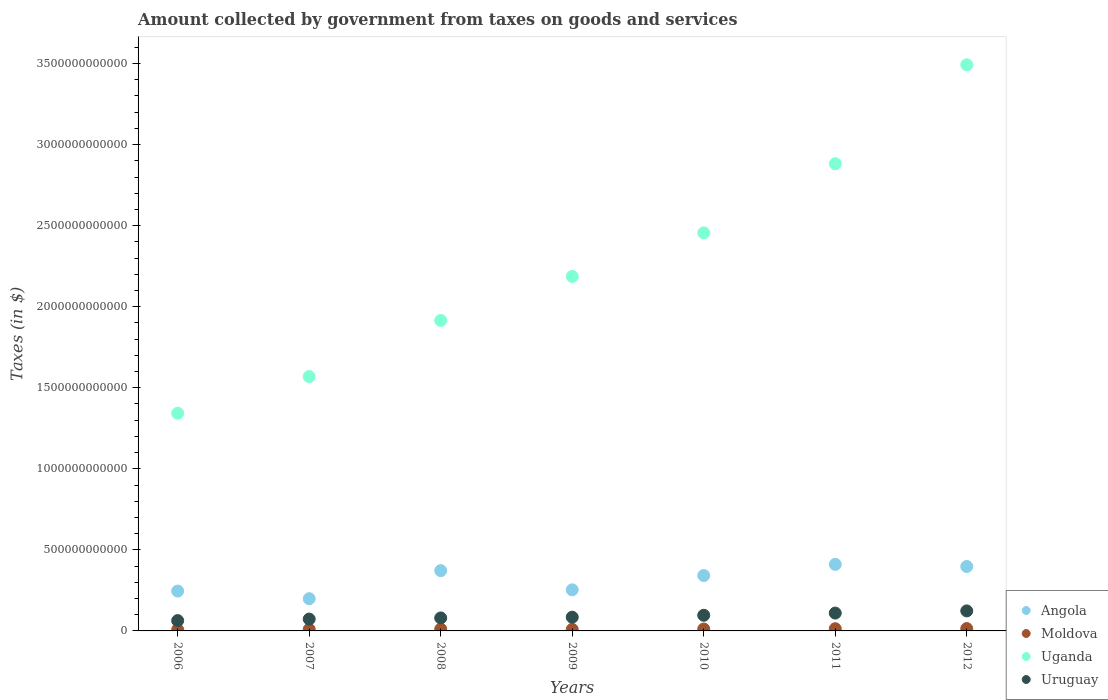What is the amount collected by government from taxes on goods and services in Uganda in 2010?
Your response must be concise. 2.46e+12. Across all years, what is the maximum amount collected by government from taxes on goods and services in Uganda?
Keep it short and to the point. 3.49e+12. Across all years, what is the minimum amount collected by government from taxes on goods and services in Uruguay?
Provide a succinct answer. 6.36e+1. What is the total amount collected by government from taxes on goods and services in Uganda in the graph?
Ensure brevity in your answer.  1.58e+13. What is the difference between the amount collected by government from taxes on goods and services in Uganda in 2008 and that in 2009?
Make the answer very short. -2.71e+11. What is the difference between the amount collected by government from taxes on goods and services in Uganda in 2006 and the amount collected by government from taxes on goods and services in Angola in 2010?
Offer a very short reply. 1.00e+12. What is the average amount collected by government from taxes on goods and services in Uruguay per year?
Keep it short and to the point. 9.02e+1. In the year 2009, what is the difference between the amount collected by government from taxes on goods and services in Angola and amount collected by government from taxes on goods and services in Uruguay?
Provide a succinct answer. 1.69e+11. In how many years, is the amount collected by government from taxes on goods and services in Angola greater than 100000000000 $?
Offer a very short reply. 7. What is the ratio of the amount collected by government from taxes on goods and services in Moldova in 2007 to that in 2011?
Your answer should be very brief. 0.69. What is the difference between the highest and the second highest amount collected by government from taxes on goods and services in Uruguay?
Offer a terse response. 1.34e+1. What is the difference between the highest and the lowest amount collected by government from taxes on goods and services in Moldova?
Your answer should be very brief. 6.71e+09. In how many years, is the amount collected by government from taxes on goods and services in Angola greater than the average amount collected by government from taxes on goods and services in Angola taken over all years?
Provide a succinct answer. 4. Does the amount collected by government from taxes on goods and services in Uruguay monotonically increase over the years?
Give a very brief answer. Yes. How many dotlines are there?
Give a very brief answer. 4. How many years are there in the graph?
Make the answer very short. 7. What is the difference between two consecutive major ticks on the Y-axis?
Give a very brief answer. 5.00e+11. Does the graph contain any zero values?
Your response must be concise. No. Does the graph contain grids?
Offer a terse response. No. Where does the legend appear in the graph?
Provide a short and direct response. Bottom right. How many legend labels are there?
Keep it short and to the point. 4. What is the title of the graph?
Give a very brief answer. Amount collected by government from taxes on goods and services. Does "Sri Lanka" appear as one of the legend labels in the graph?
Make the answer very short. No. What is the label or title of the X-axis?
Your response must be concise. Years. What is the label or title of the Y-axis?
Provide a short and direct response. Taxes (in $). What is the Taxes (in $) in Angola in 2006?
Provide a short and direct response. 2.46e+11. What is the Taxes (in $) in Moldova in 2006?
Provide a succinct answer. 7.69e+09. What is the Taxes (in $) of Uganda in 2006?
Provide a succinct answer. 1.34e+12. What is the Taxes (in $) in Uruguay in 2006?
Provide a succinct answer. 6.36e+1. What is the Taxes (in $) of Angola in 2007?
Keep it short and to the point. 1.99e+11. What is the Taxes (in $) of Moldova in 2007?
Your answer should be very brief. 9.43e+09. What is the Taxes (in $) in Uganda in 2007?
Ensure brevity in your answer.  1.57e+12. What is the Taxes (in $) in Uruguay in 2007?
Provide a succinct answer. 7.31e+1. What is the Taxes (in $) of Angola in 2008?
Make the answer very short. 3.72e+11. What is the Taxes (in $) in Moldova in 2008?
Keep it short and to the point. 1.14e+1. What is the Taxes (in $) in Uganda in 2008?
Your answer should be very brief. 1.92e+12. What is the Taxes (in $) in Uruguay in 2008?
Ensure brevity in your answer.  8.00e+1. What is the Taxes (in $) of Angola in 2009?
Offer a terse response. 2.53e+11. What is the Taxes (in $) of Moldova in 2009?
Offer a very short reply. 9.60e+09. What is the Taxes (in $) of Uganda in 2009?
Offer a very short reply. 2.19e+12. What is the Taxes (in $) in Uruguay in 2009?
Your answer should be very brief. 8.47e+1. What is the Taxes (in $) in Angola in 2010?
Give a very brief answer. 3.42e+11. What is the Taxes (in $) of Moldova in 2010?
Ensure brevity in your answer.  1.18e+1. What is the Taxes (in $) in Uganda in 2010?
Your response must be concise. 2.46e+12. What is the Taxes (in $) in Uruguay in 2010?
Your answer should be compact. 9.64e+1. What is the Taxes (in $) in Angola in 2011?
Offer a very short reply. 4.10e+11. What is the Taxes (in $) in Moldova in 2011?
Offer a very short reply. 1.36e+1. What is the Taxes (in $) of Uganda in 2011?
Provide a succinct answer. 2.88e+12. What is the Taxes (in $) in Uruguay in 2011?
Give a very brief answer. 1.10e+11. What is the Taxes (in $) of Angola in 2012?
Make the answer very short. 3.98e+11. What is the Taxes (in $) in Moldova in 2012?
Make the answer very short. 1.44e+1. What is the Taxes (in $) in Uganda in 2012?
Your answer should be very brief. 3.49e+12. What is the Taxes (in $) of Uruguay in 2012?
Provide a short and direct response. 1.23e+11. Across all years, what is the maximum Taxes (in $) in Angola?
Ensure brevity in your answer.  4.10e+11. Across all years, what is the maximum Taxes (in $) in Moldova?
Ensure brevity in your answer.  1.44e+1. Across all years, what is the maximum Taxes (in $) in Uganda?
Your response must be concise. 3.49e+12. Across all years, what is the maximum Taxes (in $) of Uruguay?
Provide a succinct answer. 1.23e+11. Across all years, what is the minimum Taxes (in $) of Angola?
Ensure brevity in your answer.  1.99e+11. Across all years, what is the minimum Taxes (in $) in Moldova?
Provide a succinct answer. 7.69e+09. Across all years, what is the minimum Taxes (in $) in Uganda?
Offer a terse response. 1.34e+12. Across all years, what is the minimum Taxes (in $) of Uruguay?
Ensure brevity in your answer.  6.36e+1. What is the total Taxes (in $) of Angola in the graph?
Ensure brevity in your answer.  2.22e+12. What is the total Taxes (in $) in Moldova in the graph?
Your answer should be compact. 7.79e+1. What is the total Taxes (in $) of Uganda in the graph?
Your answer should be compact. 1.58e+13. What is the total Taxes (in $) of Uruguay in the graph?
Your response must be concise. 6.31e+11. What is the difference between the Taxes (in $) in Angola in 2006 and that in 2007?
Ensure brevity in your answer.  4.70e+1. What is the difference between the Taxes (in $) of Moldova in 2006 and that in 2007?
Ensure brevity in your answer.  -1.74e+09. What is the difference between the Taxes (in $) of Uganda in 2006 and that in 2007?
Make the answer very short. -2.26e+11. What is the difference between the Taxes (in $) of Uruguay in 2006 and that in 2007?
Offer a terse response. -9.46e+09. What is the difference between the Taxes (in $) of Angola in 2006 and that in 2008?
Your answer should be compact. -1.26e+11. What is the difference between the Taxes (in $) of Moldova in 2006 and that in 2008?
Provide a succinct answer. -3.71e+09. What is the difference between the Taxes (in $) in Uganda in 2006 and that in 2008?
Offer a very short reply. -5.72e+11. What is the difference between the Taxes (in $) of Uruguay in 2006 and that in 2008?
Offer a terse response. -1.64e+1. What is the difference between the Taxes (in $) in Angola in 2006 and that in 2009?
Your answer should be very brief. -7.65e+09. What is the difference between the Taxes (in $) of Moldova in 2006 and that in 2009?
Keep it short and to the point. -1.91e+09. What is the difference between the Taxes (in $) of Uganda in 2006 and that in 2009?
Offer a very short reply. -8.44e+11. What is the difference between the Taxes (in $) in Uruguay in 2006 and that in 2009?
Offer a very short reply. -2.10e+1. What is the difference between the Taxes (in $) in Angola in 2006 and that in 2010?
Offer a very short reply. -9.57e+1. What is the difference between the Taxes (in $) of Moldova in 2006 and that in 2010?
Make the answer very short. -4.10e+09. What is the difference between the Taxes (in $) in Uganda in 2006 and that in 2010?
Keep it short and to the point. -1.11e+12. What is the difference between the Taxes (in $) in Uruguay in 2006 and that in 2010?
Make the answer very short. -3.28e+1. What is the difference between the Taxes (in $) of Angola in 2006 and that in 2011?
Provide a short and direct response. -1.65e+11. What is the difference between the Taxes (in $) in Moldova in 2006 and that in 2011?
Make the answer very short. -5.93e+09. What is the difference between the Taxes (in $) of Uganda in 2006 and that in 2011?
Provide a succinct answer. -1.54e+12. What is the difference between the Taxes (in $) in Uruguay in 2006 and that in 2011?
Make the answer very short. -4.64e+1. What is the difference between the Taxes (in $) of Angola in 2006 and that in 2012?
Your response must be concise. -1.52e+11. What is the difference between the Taxes (in $) of Moldova in 2006 and that in 2012?
Your answer should be compact. -6.71e+09. What is the difference between the Taxes (in $) in Uganda in 2006 and that in 2012?
Offer a terse response. -2.15e+12. What is the difference between the Taxes (in $) of Uruguay in 2006 and that in 2012?
Your answer should be compact. -5.98e+1. What is the difference between the Taxes (in $) of Angola in 2007 and that in 2008?
Your answer should be very brief. -1.73e+11. What is the difference between the Taxes (in $) in Moldova in 2007 and that in 2008?
Your answer should be very brief. -1.97e+09. What is the difference between the Taxes (in $) in Uganda in 2007 and that in 2008?
Your response must be concise. -3.46e+11. What is the difference between the Taxes (in $) of Uruguay in 2007 and that in 2008?
Provide a short and direct response. -6.92e+09. What is the difference between the Taxes (in $) in Angola in 2007 and that in 2009?
Offer a very short reply. -5.47e+1. What is the difference between the Taxes (in $) in Moldova in 2007 and that in 2009?
Offer a terse response. -1.71e+08. What is the difference between the Taxes (in $) in Uganda in 2007 and that in 2009?
Ensure brevity in your answer.  -6.18e+11. What is the difference between the Taxes (in $) in Uruguay in 2007 and that in 2009?
Provide a succinct answer. -1.16e+1. What is the difference between the Taxes (in $) in Angola in 2007 and that in 2010?
Provide a succinct answer. -1.43e+11. What is the difference between the Taxes (in $) of Moldova in 2007 and that in 2010?
Provide a succinct answer. -2.36e+09. What is the difference between the Taxes (in $) of Uganda in 2007 and that in 2010?
Ensure brevity in your answer.  -8.86e+11. What is the difference between the Taxes (in $) of Uruguay in 2007 and that in 2010?
Make the answer very short. -2.33e+1. What is the difference between the Taxes (in $) of Angola in 2007 and that in 2011?
Provide a short and direct response. -2.12e+11. What is the difference between the Taxes (in $) of Moldova in 2007 and that in 2011?
Provide a succinct answer. -4.19e+09. What is the difference between the Taxes (in $) of Uganda in 2007 and that in 2011?
Your answer should be compact. -1.31e+12. What is the difference between the Taxes (in $) in Uruguay in 2007 and that in 2011?
Offer a terse response. -3.69e+1. What is the difference between the Taxes (in $) of Angola in 2007 and that in 2012?
Your answer should be compact. -1.99e+11. What is the difference between the Taxes (in $) in Moldova in 2007 and that in 2012?
Your response must be concise. -4.97e+09. What is the difference between the Taxes (in $) of Uganda in 2007 and that in 2012?
Your answer should be compact. -1.92e+12. What is the difference between the Taxes (in $) of Uruguay in 2007 and that in 2012?
Keep it short and to the point. -5.03e+1. What is the difference between the Taxes (in $) in Angola in 2008 and that in 2009?
Offer a very short reply. 1.18e+11. What is the difference between the Taxes (in $) of Moldova in 2008 and that in 2009?
Provide a succinct answer. 1.80e+09. What is the difference between the Taxes (in $) of Uganda in 2008 and that in 2009?
Give a very brief answer. -2.71e+11. What is the difference between the Taxes (in $) in Uruguay in 2008 and that in 2009?
Your answer should be very brief. -4.65e+09. What is the difference between the Taxes (in $) in Angola in 2008 and that in 2010?
Your response must be concise. 3.04e+1. What is the difference between the Taxes (in $) of Moldova in 2008 and that in 2010?
Make the answer very short. -3.90e+08. What is the difference between the Taxes (in $) of Uganda in 2008 and that in 2010?
Your response must be concise. -5.40e+11. What is the difference between the Taxes (in $) of Uruguay in 2008 and that in 2010?
Ensure brevity in your answer.  -1.64e+1. What is the difference between the Taxes (in $) in Angola in 2008 and that in 2011?
Ensure brevity in your answer.  -3.86e+1. What is the difference between the Taxes (in $) in Moldova in 2008 and that in 2011?
Keep it short and to the point. -2.22e+09. What is the difference between the Taxes (in $) of Uganda in 2008 and that in 2011?
Give a very brief answer. -9.67e+11. What is the difference between the Taxes (in $) of Uruguay in 2008 and that in 2011?
Your answer should be compact. -3.00e+1. What is the difference between the Taxes (in $) in Angola in 2008 and that in 2012?
Your answer should be very brief. -2.56e+1. What is the difference between the Taxes (in $) in Moldova in 2008 and that in 2012?
Ensure brevity in your answer.  -3.00e+09. What is the difference between the Taxes (in $) of Uganda in 2008 and that in 2012?
Your response must be concise. -1.58e+12. What is the difference between the Taxes (in $) in Uruguay in 2008 and that in 2012?
Keep it short and to the point. -4.34e+1. What is the difference between the Taxes (in $) in Angola in 2009 and that in 2010?
Ensure brevity in your answer.  -8.80e+1. What is the difference between the Taxes (in $) of Moldova in 2009 and that in 2010?
Your answer should be very brief. -2.19e+09. What is the difference between the Taxes (in $) in Uganda in 2009 and that in 2010?
Provide a succinct answer. -2.69e+11. What is the difference between the Taxes (in $) in Uruguay in 2009 and that in 2010?
Keep it short and to the point. -1.18e+1. What is the difference between the Taxes (in $) in Angola in 2009 and that in 2011?
Make the answer very short. -1.57e+11. What is the difference between the Taxes (in $) in Moldova in 2009 and that in 2011?
Provide a succinct answer. -4.02e+09. What is the difference between the Taxes (in $) in Uganda in 2009 and that in 2011?
Your answer should be compact. -6.95e+11. What is the difference between the Taxes (in $) of Uruguay in 2009 and that in 2011?
Keep it short and to the point. -2.54e+1. What is the difference between the Taxes (in $) in Angola in 2009 and that in 2012?
Ensure brevity in your answer.  -1.44e+11. What is the difference between the Taxes (in $) of Moldova in 2009 and that in 2012?
Give a very brief answer. -4.80e+09. What is the difference between the Taxes (in $) of Uganda in 2009 and that in 2012?
Your response must be concise. -1.31e+12. What is the difference between the Taxes (in $) in Uruguay in 2009 and that in 2012?
Offer a terse response. -3.87e+1. What is the difference between the Taxes (in $) in Angola in 2010 and that in 2011?
Your answer should be very brief. -6.89e+1. What is the difference between the Taxes (in $) in Moldova in 2010 and that in 2011?
Your response must be concise. -1.83e+09. What is the difference between the Taxes (in $) in Uganda in 2010 and that in 2011?
Provide a succinct answer. -4.26e+11. What is the difference between the Taxes (in $) in Uruguay in 2010 and that in 2011?
Offer a terse response. -1.36e+1. What is the difference between the Taxes (in $) in Angola in 2010 and that in 2012?
Make the answer very short. -5.60e+1. What is the difference between the Taxes (in $) of Moldova in 2010 and that in 2012?
Your response must be concise. -2.61e+09. What is the difference between the Taxes (in $) of Uganda in 2010 and that in 2012?
Your answer should be very brief. -1.04e+12. What is the difference between the Taxes (in $) in Uruguay in 2010 and that in 2012?
Ensure brevity in your answer.  -2.70e+1. What is the difference between the Taxes (in $) of Angola in 2011 and that in 2012?
Provide a succinct answer. 1.29e+1. What is the difference between the Taxes (in $) in Moldova in 2011 and that in 2012?
Provide a short and direct response. -7.78e+08. What is the difference between the Taxes (in $) of Uganda in 2011 and that in 2012?
Provide a succinct answer. -6.10e+11. What is the difference between the Taxes (in $) of Uruguay in 2011 and that in 2012?
Ensure brevity in your answer.  -1.34e+1. What is the difference between the Taxes (in $) in Angola in 2006 and the Taxes (in $) in Moldova in 2007?
Keep it short and to the point. 2.36e+11. What is the difference between the Taxes (in $) of Angola in 2006 and the Taxes (in $) of Uganda in 2007?
Provide a succinct answer. -1.32e+12. What is the difference between the Taxes (in $) of Angola in 2006 and the Taxes (in $) of Uruguay in 2007?
Your answer should be very brief. 1.73e+11. What is the difference between the Taxes (in $) of Moldova in 2006 and the Taxes (in $) of Uganda in 2007?
Provide a short and direct response. -1.56e+12. What is the difference between the Taxes (in $) in Moldova in 2006 and the Taxes (in $) in Uruguay in 2007?
Your response must be concise. -6.54e+1. What is the difference between the Taxes (in $) of Uganda in 2006 and the Taxes (in $) of Uruguay in 2007?
Offer a terse response. 1.27e+12. What is the difference between the Taxes (in $) of Angola in 2006 and the Taxes (in $) of Moldova in 2008?
Your answer should be very brief. 2.34e+11. What is the difference between the Taxes (in $) of Angola in 2006 and the Taxes (in $) of Uganda in 2008?
Ensure brevity in your answer.  -1.67e+12. What is the difference between the Taxes (in $) of Angola in 2006 and the Taxes (in $) of Uruguay in 2008?
Offer a very short reply. 1.66e+11. What is the difference between the Taxes (in $) of Moldova in 2006 and the Taxes (in $) of Uganda in 2008?
Your answer should be compact. -1.91e+12. What is the difference between the Taxes (in $) of Moldova in 2006 and the Taxes (in $) of Uruguay in 2008?
Ensure brevity in your answer.  -7.23e+1. What is the difference between the Taxes (in $) of Uganda in 2006 and the Taxes (in $) of Uruguay in 2008?
Your answer should be compact. 1.26e+12. What is the difference between the Taxes (in $) of Angola in 2006 and the Taxes (in $) of Moldova in 2009?
Your response must be concise. 2.36e+11. What is the difference between the Taxes (in $) in Angola in 2006 and the Taxes (in $) in Uganda in 2009?
Provide a short and direct response. -1.94e+12. What is the difference between the Taxes (in $) in Angola in 2006 and the Taxes (in $) in Uruguay in 2009?
Your answer should be compact. 1.61e+11. What is the difference between the Taxes (in $) in Moldova in 2006 and the Taxes (in $) in Uganda in 2009?
Make the answer very short. -2.18e+12. What is the difference between the Taxes (in $) of Moldova in 2006 and the Taxes (in $) of Uruguay in 2009?
Your answer should be very brief. -7.70e+1. What is the difference between the Taxes (in $) of Uganda in 2006 and the Taxes (in $) of Uruguay in 2009?
Make the answer very short. 1.26e+12. What is the difference between the Taxes (in $) in Angola in 2006 and the Taxes (in $) in Moldova in 2010?
Your answer should be very brief. 2.34e+11. What is the difference between the Taxes (in $) in Angola in 2006 and the Taxes (in $) in Uganda in 2010?
Your answer should be compact. -2.21e+12. What is the difference between the Taxes (in $) in Angola in 2006 and the Taxes (in $) in Uruguay in 2010?
Keep it short and to the point. 1.49e+11. What is the difference between the Taxes (in $) in Moldova in 2006 and the Taxes (in $) in Uganda in 2010?
Your answer should be very brief. -2.45e+12. What is the difference between the Taxes (in $) in Moldova in 2006 and the Taxes (in $) in Uruguay in 2010?
Provide a succinct answer. -8.87e+1. What is the difference between the Taxes (in $) of Uganda in 2006 and the Taxes (in $) of Uruguay in 2010?
Offer a very short reply. 1.25e+12. What is the difference between the Taxes (in $) in Angola in 2006 and the Taxes (in $) in Moldova in 2011?
Ensure brevity in your answer.  2.32e+11. What is the difference between the Taxes (in $) in Angola in 2006 and the Taxes (in $) in Uganda in 2011?
Make the answer very short. -2.64e+12. What is the difference between the Taxes (in $) in Angola in 2006 and the Taxes (in $) in Uruguay in 2011?
Your response must be concise. 1.36e+11. What is the difference between the Taxes (in $) of Moldova in 2006 and the Taxes (in $) of Uganda in 2011?
Offer a very short reply. -2.87e+12. What is the difference between the Taxes (in $) in Moldova in 2006 and the Taxes (in $) in Uruguay in 2011?
Provide a short and direct response. -1.02e+11. What is the difference between the Taxes (in $) of Uganda in 2006 and the Taxes (in $) of Uruguay in 2011?
Ensure brevity in your answer.  1.23e+12. What is the difference between the Taxes (in $) in Angola in 2006 and the Taxes (in $) in Moldova in 2012?
Offer a very short reply. 2.31e+11. What is the difference between the Taxes (in $) in Angola in 2006 and the Taxes (in $) in Uganda in 2012?
Your answer should be compact. -3.25e+12. What is the difference between the Taxes (in $) of Angola in 2006 and the Taxes (in $) of Uruguay in 2012?
Make the answer very short. 1.22e+11. What is the difference between the Taxes (in $) in Moldova in 2006 and the Taxes (in $) in Uganda in 2012?
Your answer should be very brief. -3.48e+12. What is the difference between the Taxes (in $) of Moldova in 2006 and the Taxes (in $) of Uruguay in 2012?
Ensure brevity in your answer.  -1.16e+11. What is the difference between the Taxes (in $) in Uganda in 2006 and the Taxes (in $) in Uruguay in 2012?
Your answer should be very brief. 1.22e+12. What is the difference between the Taxes (in $) in Angola in 2007 and the Taxes (in $) in Moldova in 2008?
Provide a short and direct response. 1.87e+11. What is the difference between the Taxes (in $) in Angola in 2007 and the Taxes (in $) in Uganda in 2008?
Give a very brief answer. -1.72e+12. What is the difference between the Taxes (in $) of Angola in 2007 and the Taxes (in $) of Uruguay in 2008?
Provide a short and direct response. 1.19e+11. What is the difference between the Taxes (in $) of Moldova in 2007 and the Taxes (in $) of Uganda in 2008?
Your response must be concise. -1.91e+12. What is the difference between the Taxes (in $) in Moldova in 2007 and the Taxes (in $) in Uruguay in 2008?
Make the answer very short. -7.06e+1. What is the difference between the Taxes (in $) in Uganda in 2007 and the Taxes (in $) in Uruguay in 2008?
Your response must be concise. 1.49e+12. What is the difference between the Taxes (in $) of Angola in 2007 and the Taxes (in $) of Moldova in 2009?
Give a very brief answer. 1.89e+11. What is the difference between the Taxes (in $) of Angola in 2007 and the Taxes (in $) of Uganda in 2009?
Provide a short and direct response. -1.99e+12. What is the difference between the Taxes (in $) in Angola in 2007 and the Taxes (in $) in Uruguay in 2009?
Offer a very short reply. 1.14e+11. What is the difference between the Taxes (in $) of Moldova in 2007 and the Taxes (in $) of Uganda in 2009?
Offer a very short reply. -2.18e+12. What is the difference between the Taxes (in $) of Moldova in 2007 and the Taxes (in $) of Uruguay in 2009?
Provide a short and direct response. -7.52e+1. What is the difference between the Taxes (in $) of Uganda in 2007 and the Taxes (in $) of Uruguay in 2009?
Keep it short and to the point. 1.48e+12. What is the difference between the Taxes (in $) of Angola in 2007 and the Taxes (in $) of Moldova in 2010?
Make the answer very short. 1.87e+11. What is the difference between the Taxes (in $) in Angola in 2007 and the Taxes (in $) in Uganda in 2010?
Ensure brevity in your answer.  -2.26e+12. What is the difference between the Taxes (in $) of Angola in 2007 and the Taxes (in $) of Uruguay in 2010?
Your answer should be very brief. 1.02e+11. What is the difference between the Taxes (in $) in Moldova in 2007 and the Taxes (in $) in Uganda in 2010?
Offer a very short reply. -2.45e+12. What is the difference between the Taxes (in $) in Moldova in 2007 and the Taxes (in $) in Uruguay in 2010?
Provide a succinct answer. -8.70e+1. What is the difference between the Taxes (in $) of Uganda in 2007 and the Taxes (in $) of Uruguay in 2010?
Ensure brevity in your answer.  1.47e+12. What is the difference between the Taxes (in $) of Angola in 2007 and the Taxes (in $) of Moldova in 2011?
Provide a succinct answer. 1.85e+11. What is the difference between the Taxes (in $) of Angola in 2007 and the Taxes (in $) of Uganda in 2011?
Your answer should be compact. -2.68e+12. What is the difference between the Taxes (in $) of Angola in 2007 and the Taxes (in $) of Uruguay in 2011?
Give a very brief answer. 8.87e+1. What is the difference between the Taxes (in $) of Moldova in 2007 and the Taxes (in $) of Uganda in 2011?
Your response must be concise. -2.87e+12. What is the difference between the Taxes (in $) of Moldova in 2007 and the Taxes (in $) of Uruguay in 2011?
Provide a short and direct response. -1.01e+11. What is the difference between the Taxes (in $) of Uganda in 2007 and the Taxes (in $) of Uruguay in 2011?
Your response must be concise. 1.46e+12. What is the difference between the Taxes (in $) of Angola in 2007 and the Taxes (in $) of Moldova in 2012?
Your answer should be very brief. 1.84e+11. What is the difference between the Taxes (in $) in Angola in 2007 and the Taxes (in $) in Uganda in 2012?
Your response must be concise. -3.29e+12. What is the difference between the Taxes (in $) in Angola in 2007 and the Taxes (in $) in Uruguay in 2012?
Offer a terse response. 7.54e+1. What is the difference between the Taxes (in $) of Moldova in 2007 and the Taxes (in $) of Uganda in 2012?
Provide a short and direct response. -3.48e+12. What is the difference between the Taxes (in $) of Moldova in 2007 and the Taxes (in $) of Uruguay in 2012?
Keep it short and to the point. -1.14e+11. What is the difference between the Taxes (in $) in Uganda in 2007 and the Taxes (in $) in Uruguay in 2012?
Provide a short and direct response. 1.45e+12. What is the difference between the Taxes (in $) of Angola in 2008 and the Taxes (in $) of Moldova in 2009?
Your response must be concise. 3.62e+11. What is the difference between the Taxes (in $) of Angola in 2008 and the Taxes (in $) of Uganda in 2009?
Make the answer very short. -1.81e+12. What is the difference between the Taxes (in $) in Angola in 2008 and the Taxes (in $) in Uruguay in 2009?
Your answer should be compact. 2.87e+11. What is the difference between the Taxes (in $) in Moldova in 2008 and the Taxes (in $) in Uganda in 2009?
Offer a very short reply. -2.18e+12. What is the difference between the Taxes (in $) in Moldova in 2008 and the Taxes (in $) in Uruguay in 2009?
Your answer should be compact. -7.33e+1. What is the difference between the Taxes (in $) in Uganda in 2008 and the Taxes (in $) in Uruguay in 2009?
Ensure brevity in your answer.  1.83e+12. What is the difference between the Taxes (in $) of Angola in 2008 and the Taxes (in $) of Moldova in 2010?
Provide a short and direct response. 3.60e+11. What is the difference between the Taxes (in $) in Angola in 2008 and the Taxes (in $) in Uganda in 2010?
Your answer should be very brief. -2.08e+12. What is the difference between the Taxes (in $) in Angola in 2008 and the Taxes (in $) in Uruguay in 2010?
Your response must be concise. 2.75e+11. What is the difference between the Taxes (in $) in Moldova in 2008 and the Taxes (in $) in Uganda in 2010?
Provide a succinct answer. -2.44e+12. What is the difference between the Taxes (in $) in Moldova in 2008 and the Taxes (in $) in Uruguay in 2010?
Give a very brief answer. -8.50e+1. What is the difference between the Taxes (in $) in Uganda in 2008 and the Taxes (in $) in Uruguay in 2010?
Offer a terse response. 1.82e+12. What is the difference between the Taxes (in $) in Angola in 2008 and the Taxes (in $) in Moldova in 2011?
Your answer should be very brief. 3.58e+11. What is the difference between the Taxes (in $) of Angola in 2008 and the Taxes (in $) of Uganda in 2011?
Provide a short and direct response. -2.51e+12. What is the difference between the Taxes (in $) in Angola in 2008 and the Taxes (in $) in Uruguay in 2011?
Your response must be concise. 2.62e+11. What is the difference between the Taxes (in $) of Moldova in 2008 and the Taxes (in $) of Uganda in 2011?
Provide a succinct answer. -2.87e+12. What is the difference between the Taxes (in $) in Moldova in 2008 and the Taxes (in $) in Uruguay in 2011?
Make the answer very short. -9.87e+1. What is the difference between the Taxes (in $) in Uganda in 2008 and the Taxes (in $) in Uruguay in 2011?
Your answer should be very brief. 1.81e+12. What is the difference between the Taxes (in $) in Angola in 2008 and the Taxes (in $) in Moldova in 2012?
Keep it short and to the point. 3.58e+11. What is the difference between the Taxes (in $) of Angola in 2008 and the Taxes (in $) of Uganda in 2012?
Keep it short and to the point. -3.12e+12. What is the difference between the Taxes (in $) of Angola in 2008 and the Taxes (in $) of Uruguay in 2012?
Make the answer very short. 2.48e+11. What is the difference between the Taxes (in $) in Moldova in 2008 and the Taxes (in $) in Uganda in 2012?
Your answer should be very brief. -3.48e+12. What is the difference between the Taxes (in $) of Moldova in 2008 and the Taxes (in $) of Uruguay in 2012?
Give a very brief answer. -1.12e+11. What is the difference between the Taxes (in $) in Uganda in 2008 and the Taxes (in $) in Uruguay in 2012?
Your answer should be very brief. 1.79e+12. What is the difference between the Taxes (in $) in Angola in 2009 and the Taxes (in $) in Moldova in 2010?
Keep it short and to the point. 2.42e+11. What is the difference between the Taxes (in $) of Angola in 2009 and the Taxes (in $) of Uganda in 2010?
Ensure brevity in your answer.  -2.20e+12. What is the difference between the Taxes (in $) in Angola in 2009 and the Taxes (in $) in Uruguay in 2010?
Your answer should be compact. 1.57e+11. What is the difference between the Taxes (in $) in Moldova in 2009 and the Taxes (in $) in Uganda in 2010?
Your answer should be compact. -2.45e+12. What is the difference between the Taxes (in $) in Moldova in 2009 and the Taxes (in $) in Uruguay in 2010?
Keep it short and to the point. -8.68e+1. What is the difference between the Taxes (in $) of Uganda in 2009 and the Taxes (in $) of Uruguay in 2010?
Your response must be concise. 2.09e+12. What is the difference between the Taxes (in $) of Angola in 2009 and the Taxes (in $) of Moldova in 2011?
Ensure brevity in your answer.  2.40e+11. What is the difference between the Taxes (in $) in Angola in 2009 and the Taxes (in $) in Uganda in 2011?
Provide a succinct answer. -2.63e+12. What is the difference between the Taxes (in $) of Angola in 2009 and the Taxes (in $) of Uruguay in 2011?
Your answer should be compact. 1.43e+11. What is the difference between the Taxes (in $) in Moldova in 2009 and the Taxes (in $) in Uganda in 2011?
Provide a short and direct response. -2.87e+12. What is the difference between the Taxes (in $) in Moldova in 2009 and the Taxes (in $) in Uruguay in 2011?
Give a very brief answer. -1.00e+11. What is the difference between the Taxes (in $) of Uganda in 2009 and the Taxes (in $) of Uruguay in 2011?
Offer a terse response. 2.08e+12. What is the difference between the Taxes (in $) of Angola in 2009 and the Taxes (in $) of Moldova in 2012?
Offer a very short reply. 2.39e+11. What is the difference between the Taxes (in $) of Angola in 2009 and the Taxes (in $) of Uganda in 2012?
Provide a succinct answer. -3.24e+12. What is the difference between the Taxes (in $) of Angola in 2009 and the Taxes (in $) of Uruguay in 2012?
Your answer should be compact. 1.30e+11. What is the difference between the Taxes (in $) in Moldova in 2009 and the Taxes (in $) in Uganda in 2012?
Make the answer very short. -3.48e+12. What is the difference between the Taxes (in $) of Moldova in 2009 and the Taxes (in $) of Uruguay in 2012?
Give a very brief answer. -1.14e+11. What is the difference between the Taxes (in $) of Uganda in 2009 and the Taxes (in $) of Uruguay in 2012?
Your answer should be compact. 2.06e+12. What is the difference between the Taxes (in $) in Angola in 2010 and the Taxes (in $) in Moldova in 2011?
Provide a short and direct response. 3.28e+11. What is the difference between the Taxes (in $) in Angola in 2010 and the Taxes (in $) in Uganda in 2011?
Offer a terse response. -2.54e+12. What is the difference between the Taxes (in $) in Angola in 2010 and the Taxes (in $) in Uruguay in 2011?
Give a very brief answer. 2.31e+11. What is the difference between the Taxes (in $) of Moldova in 2010 and the Taxes (in $) of Uganda in 2011?
Make the answer very short. -2.87e+12. What is the difference between the Taxes (in $) in Moldova in 2010 and the Taxes (in $) in Uruguay in 2011?
Offer a very short reply. -9.83e+1. What is the difference between the Taxes (in $) of Uganda in 2010 and the Taxes (in $) of Uruguay in 2011?
Give a very brief answer. 2.35e+12. What is the difference between the Taxes (in $) in Angola in 2010 and the Taxes (in $) in Moldova in 2012?
Make the answer very short. 3.27e+11. What is the difference between the Taxes (in $) of Angola in 2010 and the Taxes (in $) of Uganda in 2012?
Give a very brief answer. -3.15e+12. What is the difference between the Taxes (in $) in Angola in 2010 and the Taxes (in $) in Uruguay in 2012?
Provide a short and direct response. 2.18e+11. What is the difference between the Taxes (in $) in Moldova in 2010 and the Taxes (in $) in Uganda in 2012?
Ensure brevity in your answer.  -3.48e+12. What is the difference between the Taxes (in $) of Moldova in 2010 and the Taxes (in $) of Uruguay in 2012?
Your answer should be very brief. -1.12e+11. What is the difference between the Taxes (in $) in Uganda in 2010 and the Taxes (in $) in Uruguay in 2012?
Your response must be concise. 2.33e+12. What is the difference between the Taxes (in $) in Angola in 2011 and the Taxes (in $) in Moldova in 2012?
Give a very brief answer. 3.96e+11. What is the difference between the Taxes (in $) in Angola in 2011 and the Taxes (in $) in Uganda in 2012?
Make the answer very short. -3.08e+12. What is the difference between the Taxes (in $) in Angola in 2011 and the Taxes (in $) in Uruguay in 2012?
Give a very brief answer. 2.87e+11. What is the difference between the Taxes (in $) in Moldova in 2011 and the Taxes (in $) in Uganda in 2012?
Provide a short and direct response. -3.48e+12. What is the difference between the Taxes (in $) in Moldova in 2011 and the Taxes (in $) in Uruguay in 2012?
Your answer should be compact. -1.10e+11. What is the difference between the Taxes (in $) of Uganda in 2011 and the Taxes (in $) of Uruguay in 2012?
Your response must be concise. 2.76e+12. What is the average Taxes (in $) of Angola per year?
Provide a succinct answer. 3.17e+11. What is the average Taxes (in $) of Moldova per year?
Provide a succinct answer. 1.11e+1. What is the average Taxes (in $) in Uganda per year?
Give a very brief answer. 2.26e+12. What is the average Taxes (in $) of Uruguay per year?
Make the answer very short. 9.02e+1. In the year 2006, what is the difference between the Taxes (in $) of Angola and Taxes (in $) of Moldova?
Make the answer very short. 2.38e+11. In the year 2006, what is the difference between the Taxes (in $) of Angola and Taxes (in $) of Uganda?
Make the answer very short. -1.10e+12. In the year 2006, what is the difference between the Taxes (in $) of Angola and Taxes (in $) of Uruguay?
Provide a short and direct response. 1.82e+11. In the year 2006, what is the difference between the Taxes (in $) of Moldova and Taxes (in $) of Uganda?
Ensure brevity in your answer.  -1.34e+12. In the year 2006, what is the difference between the Taxes (in $) of Moldova and Taxes (in $) of Uruguay?
Give a very brief answer. -5.60e+1. In the year 2006, what is the difference between the Taxes (in $) of Uganda and Taxes (in $) of Uruguay?
Provide a short and direct response. 1.28e+12. In the year 2007, what is the difference between the Taxes (in $) of Angola and Taxes (in $) of Moldova?
Your response must be concise. 1.89e+11. In the year 2007, what is the difference between the Taxes (in $) of Angola and Taxes (in $) of Uganda?
Provide a short and direct response. -1.37e+12. In the year 2007, what is the difference between the Taxes (in $) of Angola and Taxes (in $) of Uruguay?
Make the answer very short. 1.26e+11. In the year 2007, what is the difference between the Taxes (in $) of Moldova and Taxes (in $) of Uganda?
Your answer should be compact. -1.56e+12. In the year 2007, what is the difference between the Taxes (in $) of Moldova and Taxes (in $) of Uruguay?
Your response must be concise. -6.37e+1. In the year 2007, what is the difference between the Taxes (in $) in Uganda and Taxes (in $) in Uruguay?
Offer a very short reply. 1.50e+12. In the year 2008, what is the difference between the Taxes (in $) of Angola and Taxes (in $) of Moldova?
Provide a succinct answer. 3.61e+11. In the year 2008, what is the difference between the Taxes (in $) in Angola and Taxes (in $) in Uganda?
Make the answer very short. -1.54e+12. In the year 2008, what is the difference between the Taxes (in $) in Angola and Taxes (in $) in Uruguay?
Offer a terse response. 2.92e+11. In the year 2008, what is the difference between the Taxes (in $) in Moldova and Taxes (in $) in Uganda?
Offer a very short reply. -1.90e+12. In the year 2008, what is the difference between the Taxes (in $) in Moldova and Taxes (in $) in Uruguay?
Give a very brief answer. -6.86e+1. In the year 2008, what is the difference between the Taxes (in $) in Uganda and Taxes (in $) in Uruguay?
Provide a succinct answer. 1.84e+12. In the year 2009, what is the difference between the Taxes (in $) of Angola and Taxes (in $) of Moldova?
Offer a terse response. 2.44e+11. In the year 2009, what is the difference between the Taxes (in $) in Angola and Taxes (in $) in Uganda?
Offer a very short reply. -1.93e+12. In the year 2009, what is the difference between the Taxes (in $) of Angola and Taxes (in $) of Uruguay?
Offer a terse response. 1.69e+11. In the year 2009, what is the difference between the Taxes (in $) of Moldova and Taxes (in $) of Uganda?
Your response must be concise. -2.18e+12. In the year 2009, what is the difference between the Taxes (in $) in Moldova and Taxes (in $) in Uruguay?
Make the answer very short. -7.51e+1. In the year 2009, what is the difference between the Taxes (in $) in Uganda and Taxes (in $) in Uruguay?
Provide a succinct answer. 2.10e+12. In the year 2010, what is the difference between the Taxes (in $) in Angola and Taxes (in $) in Moldova?
Give a very brief answer. 3.30e+11. In the year 2010, what is the difference between the Taxes (in $) of Angola and Taxes (in $) of Uganda?
Your answer should be very brief. -2.11e+12. In the year 2010, what is the difference between the Taxes (in $) in Angola and Taxes (in $) in Uruguay?
Keep it short and to the point. 2.45e+11. In the year 2010, what is the difference between the Taxes (in $) of Moldova and Taxes (in $) of Uganda?
Make the answer very short. -2.44e+12. In the year 2010, what is the difference between the Taxes (in $) in Moldova and Taxes (in $) in Uruguay?
Offer a very short reply. -8.47e+1. In the year 2010, what is the difference between the Taxes (in $) of Uganda and Taxes (in $) of Uruguay?
Offer a terse response. 2.36e+12. In the year 2011, what is the difference between the Taxes (in $) in Angola and Taxes (in $) in Moldova?
Provide a succinct answer. 3.97e+11. In the year 2011, what is the difference between the Taxes (in $) of Angola and Taxes (in $) of Uganda?
Provide a succinct answer. -2.47e+12. In the year 2011, what is the difference between the Taxes (in $) of Angola and Taxes (in $) of Uruguay?
Provide a succinct answer. 3.00e+11. In the year 2011, what is the difference between the Taxes (in $) of Moldova and Taxes (in $) of Uganda?
Make the answer very short. -2.87e+12. In the year 2011, what is the difference between the Taxes (in $) of Moldova and Taxes (in $) of Uruguay?
Offer a very short reply. -9.64e+1. In the year 2011, what is the difference between the Taxes (in $) of Uganda and Taxes (in $) of Uruguay?
Give a very brief answer. 2.77e+12. In the year 2012, what is the difference between the Taxes (in $) in Angola and Taxes (in $) in Moldova?
Your response must be concise. 3.83e+11. In the year 2012, what is the difference between the Taxes (in $) in Angola and Taxes (in $) in Uganda?
Your answer should be very brief. -3.09e+12. In the year 2012, what is the difference between the Taxes (in $) of Angola and Taxes (in $) of Uruguay?
Keep it short and to the point. 2.74e+11. In the year 2012, what is the difference between the Taxes (in $) of Moldova and Taxes (in $) of Uganda?
Keep it short and to the point. -3.48e+12. In the year 2012, what is the difference between the Taxes (in $) of Moldova and Taxes (in $) of Uruguay?
Ensure brevity in your answer.  -1.09e+11. In the year 2012, what is the difference between the Taxes (in $) of Uganda and Taxes (in $) of Uruguay?
Offer a very short reply. 3.37e+12. What is the ratio of the Taxes (in $) of Angola in 2006 to that in 2007?
Make the answer very short. 1.24. What is the ratio of the Taxes (in $) of Moldova in 2006 to that in 2007?
Provide a short and direct response. 0.82. What is the ratio of the Taxes (in $) in Uganda in 2006 to that in 2007?
Keep it short and to the point. 0.86. What is the ratio of the Taxes (in $) of Uruguay in 2006 to that in 2007?
Provide a short and direct response. 0.87. What is the ratio of the Taxes (in $) of Angola in 2006 to that in 2008?
Provide a succinct answer. 0.66. What is the ratio of the Taxes (in $) in Moldova in 2006 to that in 2008?
Ensure brevity in your answer.  0.67. What is the ratio of the Taxes (in $) in Uganda in 2006 to that in 2008?
Offer a terse response. 0.7. What is the ratio of the Taxes (in $) in Uruguay in 2006 to that in 2008?
Make the answer very short. 0.8. What is the ratio of the Taxes (in $) of Angola in 2006 to that in 2009?
Keep it short and to the point. 0.97. What is the ratio of the Taxes (in $) in Moldova in 2006 to that in 2009?
Offer a terse response. 0.8. What is the ratio of the Taxes (in $) in Uganda in 2006 to that in 2009?
Provide a short and direct response. 0.61. What is the ratio of the Taxes (in $) of Uruguay in 2006 to that in 2009?
Offer a very short reply. 0.75. What is the ratio of the Taxes (in $) of Angola in 2006 to that in 2010?
Keep it short and to the point. 0.72. What is the ratio of the Taxes (in $) in Moldova in 2006 to that in 2010?
Your response must be concise. 0.65. What is the ratio of the Taxes (in $) of Uganda in 2006 to that in 2010?
Provide a short and direct response. 0.55. What is the ratio of the Taxes (in $) of Uruguay in 2006 to that in 2010?
Offer a very short reply. 0.66. What is the ratio of the Taxes (in $) in Angola in 2006 to that in 2011?
Offer a terse response. 0.6. What is the ratio of the Taxes (in $) of Moldova in 2006 to that in 2011?
Give a very brief answer. 0.56. What is the ratio of the Taxes (in $) in Uganda in 2006 to that in 2011?
Ensure brevity in your answer.  0.47. What is the ratio of the Taxes (in $) of Uruguay in 2006 to that in 2011?
Give a very brief answer. 0.58. What is the ratio of the Taxes (in $) of Angola in 2006 to that in 2012?
Keep it short and to the point. 0.62. What is the ratio of the Taxes (in $) of Moldova in 2006 to that in 2012?
Your answer should be very brief. 0.53. What is the ratio of the Taxes (in $) of Uganda in 2006 to that in 2012?
Provide a succinct answer. 0.38. What is the ratio of the Taxes (in $) in Uruguay in 2006 to that in 2012?
Make the answer very short. 0.52. What is the ratio of the Taxes (in $) in Angola in 2007 to that in 2008?
Keep it short and to the point. 0.53. What is the ratio of the Taxes (in $) in Moldova in 2007 to that in 2008?
Your response must be concise. 0.83. What is the ratio of the Taxes (in $) in Uganda in 2007 to that in 2008?
Offer a terse response. 0.82. What is the ratio of the Taxes (in $) in Uruguay in 2007 to that in 2008?
Ensure brevity in your answer.  0.91. What is the ratio of the Taxes (in $) in Angola in 2007 to that in 2009?
Keep it short and to the point. 0.78. What is the ratio of the Taxes (in $) of Moldova in 2007 to that in 2009?
Keep it short and to the point. 0.98. What is the ratio of the Taxes (in $) of Uganda in 2007 to that in 2009?
Give a very brief answer. 0.72. What is the ratio of the Taxes (in $) in Uruguay in 2007 to that in 2009?
Provide a short and direct response. 0.86. What is the ratio of the Taxes (in $) in Angola in 2007 to that in 2010?
Ensure brevity in your answer.  0.58. What is the ratio of the Taxes (in $) in Moldova in 2007 to that in 2010?
Keep it short and to the point. 0.8. What is the ratio of the Taxes (in $) in Uganda in 2007 to that in 2010?
Your answer should be very brief. 0.64. What is the ratio of the Taxes (in $) of Uruguay in 2007 to that in 2010?
Make the answer very short. 0.76. What is the ratio of the Taxes (in $) of Angola in 2007 to that in 2011?
Your answer should be very brief. 0.48. What is the ratio of the Taxes (in $) in Moldova in 2007 to that in 2011?
Keep it short and to the point. 0.69. What is the ratio of the Taxes (in $) of Uganda in 2007 to that in 2011?
Your answer should be very brief. 0.54. What is the ratio of the Taxes (in $) of Uruguay in 2007 to that in 2011?
Make the answer very short. 0.66. What is the ratio of the Taxes (in $) in Angola in 2007 to that in 2012?
Make the answer very short. 0.5. What is the ratio of the Taxes (in $) in Moldova in 2007 to that in 2012?
Make the answer very short. 0.65. What is the ratio of the Taxes (in $) of Uganda in 2007 to that in 2012?
Give a very brief answer. 0.45. What is the ratio of the Taxes (in $) of Uruguay in 2007 to that in 2012?
Keep it short and to the point. 0.59. What is the ratio of the Taxes (in $) of Angola in 2008 to that in 2009?
Keep it short and to the point. 1.47. What is the ratio of the Taxes (in $) in Moldova in 2008 to that in 2009?
Your answer should be very brief. 1.19. What is the ratio of the Taxes (in $) of Uganda in 2008 to that in 2009?
Give a very brief answer. 0.88. What is the ratio of the Taxes (in $) in Uruguay in 2008 to that in 2009?
Keep it short and to the point. 0.95. What is the ratio of the Taxes (in $) in Angola in 2008 to that in 2010?
Ensure brevity in your answer.  1.09. What is the ratio of the Taxes (in $) of Moldova in 2008 to that in 2010?
Your answer should be compact. 0.97. What is the ratio of the Taxes (in $) of Uganda in 2008 to that in 2010?
Provide a short and direct response. 0.78. What is the ratio of the Taxes (in $) in Uruguay in 2008 to that in 2010?
Your answer should be very brief. 0.83. What is the ratio of the Taxes (in $) of Angola in 2008 to that in 2011?
Provide a short and direct response. 0.91. What is the ratio of the Taxes (in $) in Moldova in 2008 to that in 2011?
Make the answer very short. 0.84. What is the ratio of the Taxes (in $) of Uganda in 2008 to that in 2011?
Offer a very short reply. 0.66. What is the ratio of the Taxes (in $) in Uruguay in 2008 to that in 2011?
Your answer should be compact. 0.73. What is the ratio of the Taxes (in $) of Angola in 2008 to that in 2012?
Make the answer very short. 0.94. What is the ratio of the Taxes (in $) in Moldova in 2008 to that in 2012?
Offer a terse response. 0.79. What is the ratio of the Taxes (in $) in Uganda in 2008 to that in 2012?
Ensure brevity in your answer.  0.55. What is the ratio of the Taxes (in $) in Uruguay in 2008 to that in 2012?
Provide a short and direct response. 0.65. What is the ratio of the Taxes (in $) of Angola in 2009 to that in 2010?
Offer a terse response. 0.74. What is the ratio of the Taxes (in $) in Moldova in 2009 to that in 2010?
Your answer should be compact. 0.81. What is the ratio of the Taxes (in $) of Uganda in 2009 to that in 2010?
Provide a succinct answer. 0.89. What is the ratio of the Taxes (in $) of Uruguay in 2009 to that in 2010?
Your answer should be compact. 0.88. What is the ratio of the Taxes (in $) in Angola in 2009 to that in 2011?
Your answer should be very brief. 0.62. What is the ratio of the Taxes (in $) in Moldova in 2009 to that in 2011?
Keep it short and to the point. 0.7. What is the ratio of the Taxes (in $) of Uganda in 2009 to that in 2011?
Give a very brief answer. 0.76. What is the ratio of the Taxes (in $) in Uruguay in 2009 to that in 2011?
Keep it short and to the point. 0.77. What is the ratio of the Taxes (in $) of Angola in 2009 to that in 2012?
Ensure brevity in your answer.  0.64. What is the ratio of the Taxes (in $) of Moldova in 2009 to that in 2012?
Offer a terse response. 0.67. What is the ratio of the Taxes (in $) in Uganda in 2009 to that in 2012?
Your answer should be very brief. 0.63. What is the ratio of the Taxes (in $) in Uruguay in 2009 to that in 2012?
Provide a short and direct response. 0.69. What is the ratio of the Taxes (in $) in Angola in 2010 to that in 2011?
Ensure brevity in your answer.  0.83. What is the ratio of the Taxes (in $) in Moldova in 2010 to that in 2011?
Ensure brevity in your answer.  0.87. What is the ratio of the Taxes (in $) in Uganda in 2010 to that in 2011?
Your answer should be compact. 0.85. What is the ratio of the Taxes (in $) in Uruguay in 2010 to that in 2011?
Provide a succinct answer. 0.88. What is the ratio of the Taxes (in $) in Angola in 2010 to that in 2012?
Provide a succinct answer. 0.86. What is the ratio of the Taxes (in $) of Moldova in 2010 to that in 2012?
Offer a terse response. 0.82. What is the ratio of the Taxes (in $) of Uganda in 2010 to that in 2012?
Provide a short and direct response. 0.7. What is the ratio of the Taxes (in $) in Uruguay in 2010 to that in 2012?
Make the answer very short. 0.78. What is the ratio of the Taxes (in $) in Angola in 2011 to that in 2012?
Your response must be concise. 1.03. What is the ratio of the Taxes (in $) in Moldova in 2011 to that in 2012?
Offer a terse response. 0.95. What is the ratio of the Taxes (in $) of Uganda in 2011 to that in 2012?
Your response must be concise. 0.83. What is the ratio of the Taxes (in $) of Uruguay in 2011 to that in 2012?
Give a very brief answer. 0.89. What is the difference between the highest and the second highest Taxes (in $) of Angola?
Your answer should be very brief. 1.29e+1. What is the difference between the highest and the second highest Taxes (in $) in Moldova?
Provide a succinct answer. 7.78e+08. What is the difference between the highest and the second highest Taxes (in $) of Uganda?
Ensure brevity in your answer.  6.10e+11. What is the difference between the highest and the second highest Taxes (in $) in Uruguay?
Your answer should be compact. 1.34e+1. What is the difference between the highest and the lowest Taxes (in $) of Angola?
Provide a short and direct response. 2.12e+11. What is the difference between the highest and the lowest Taxes (in $) of Moldova?
Ensure brevity in your answer.  6.71e+09. What is the difference between the highest and the lowest Taxes (in $) of Uganda?
Give a very brief answer. 2.15e+12. What is the difference between the highest and the lowest Taxes (in $) of Uruguay?
Make the answer very short. 5.98e+1. 